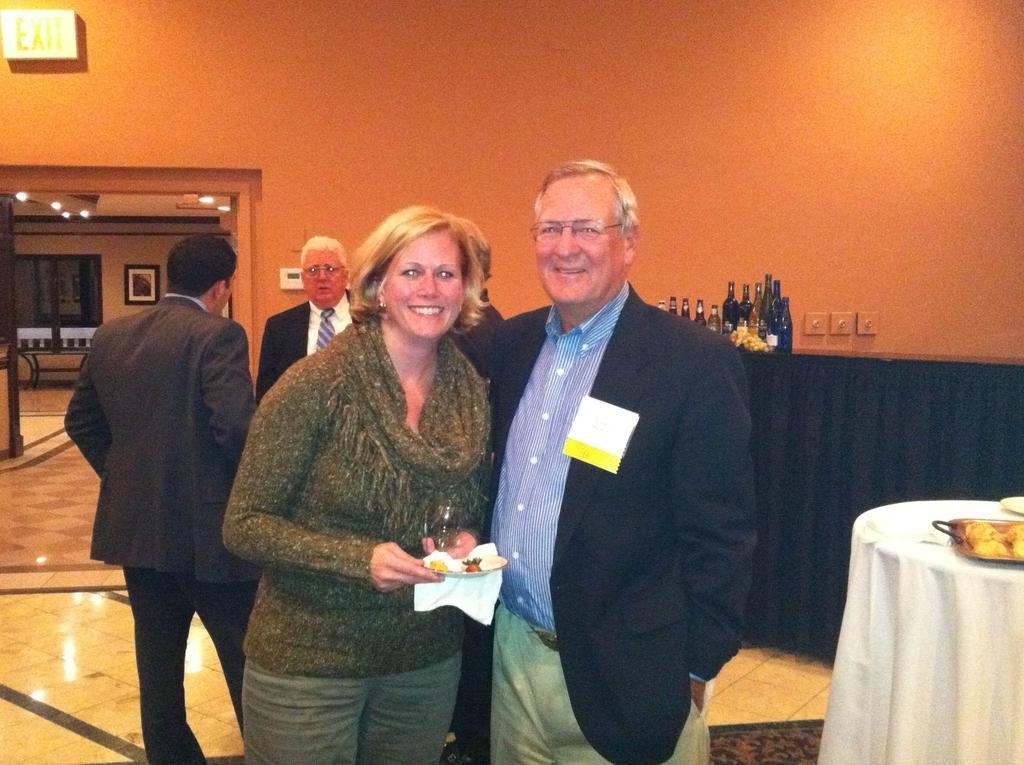In one or two sentences, can you explain what this image depicts? In this image we can see some group of persons standing, in the foreground of the image there is a couple, male wearing suit and female wearing green color dress and also holding some glass and some food item in her hands, on right side of the image we can see some thing on table and in the background of image there are some bottles on table, there is a wall, door and some paintings attached to the wall. 